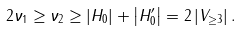Convert formula to latex. <formula><loc_0><loc_0><loc_500><loc_500>2 \nu _ { 1 } \geq \nu _ { 2 } \geq \left | H _ { 0 } \right | + \left | H _ { 0 } ^ { \prime } \right | = 2 \left | V _ { \geq 3 } \right | .</formula> 